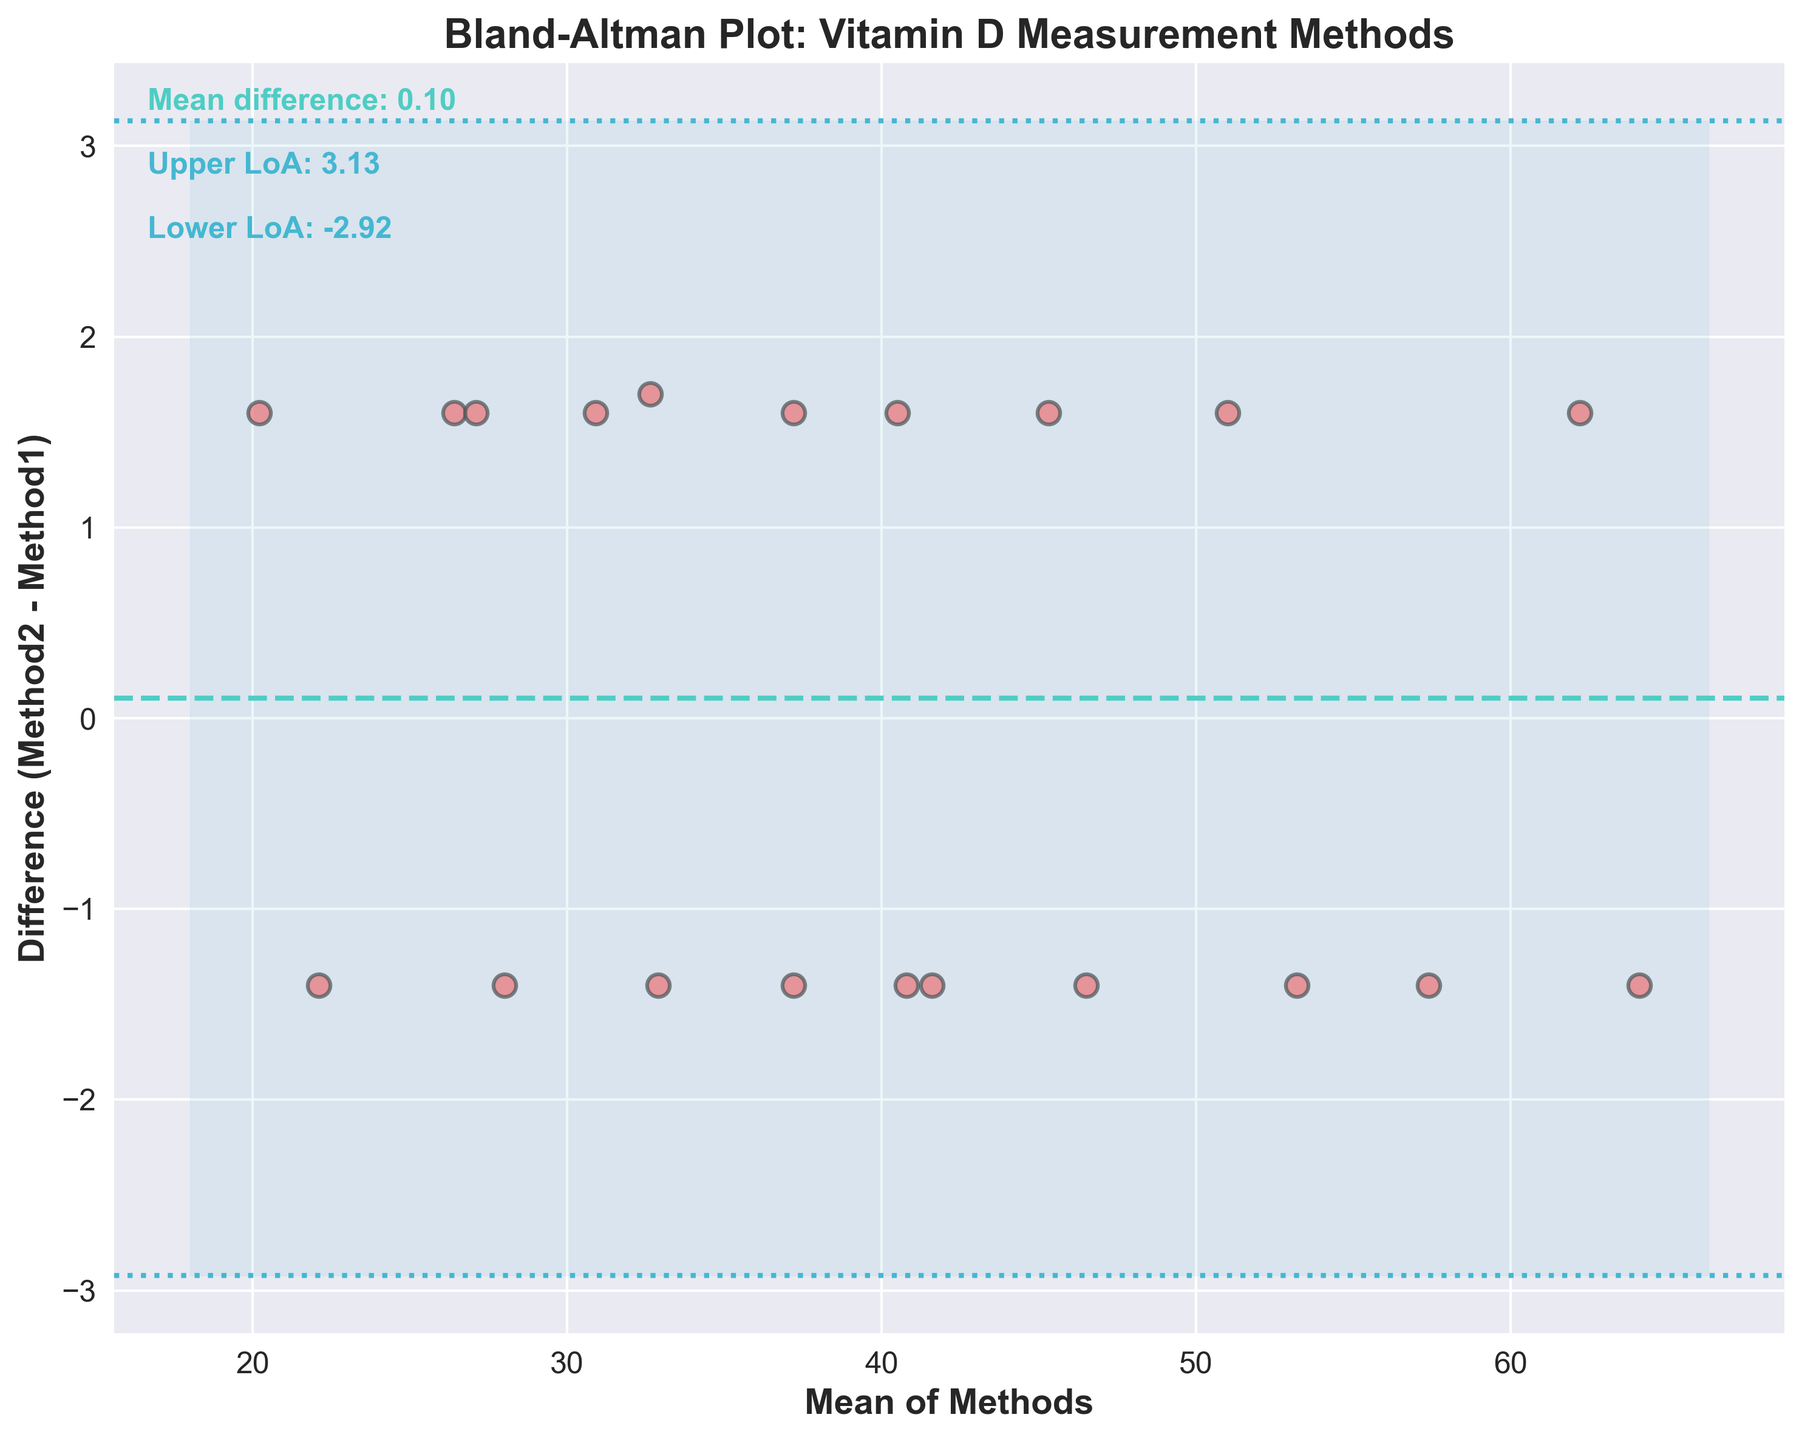What is the title of the plot? The title is displayed at the top of the plot and reads, "Bland-Altman Plot: Vitamin D Measurement Methods."
Answer: Bland-Altman Plot: Vitamin D Measurement Methods What is the mean of the differences between the two methods? The mean of the differences is displayed as a horizontal dashed line. The text label on the plot indicates "Mean difference: 0.15."
Answer: 0.15 How many data points are plotted on the Bland-Altman plot? Each data point is represented by a scatter plot marker. Counting all markers gives the total number of data points, which is 20.
Answer: 20 What do the horizontal dotted lines represent? The horizontal dotted lines represent the limits of agreement, which are calculated as the mean difference ± 1.96 times the standard deviation of the differences. The upper limit is labeled as "Upper LoA: 2.83" and the lower limit is labeled as "Lower LoA: -2.53."
Answer: Limits of agreement Is the difference between the two methods more likely to be positive or negative? Given that the mean difference of 0.15 is slightly above zero, it indicates that the differences are more likely to be positive on average.
Answer: Positive What is the range of the differences plotted on the y-axis? The range of differences can be inferred from the y-axis values. The plot shows differences from approximately -3 to 3.
Answer: -3 to 3 What is the mean of the Vitamin D levels measured by Method1 and Method2 at the point where the difference is the biggest? The biggest difference appears to be around 3.0 on the y-axis from the scatter plot. Find the corresponding x-value (mean of the methods), which is around 45 to 50, based on the x-axis.
Answer: 45 to 50 Which method generally reports higher Vitamin D levels? Method2 generally reports slightly higher Vitamin D levels as the mean difference (Method2 - Method1) is positive (0.15).
Answer: Method2 Do any data points lie outside the limits of agreement? Observe the scatter plot to see if any data points fall outside the horizontal dotted lines. No data points visibly fall outside these lines.
Answer: No Are the methods sufficiently concordant? The majority of differences lie within the limits of agreement, and the mean difference is close to zero, indicating that there is sufficient concordance between the two methods.
Answer: Yes 